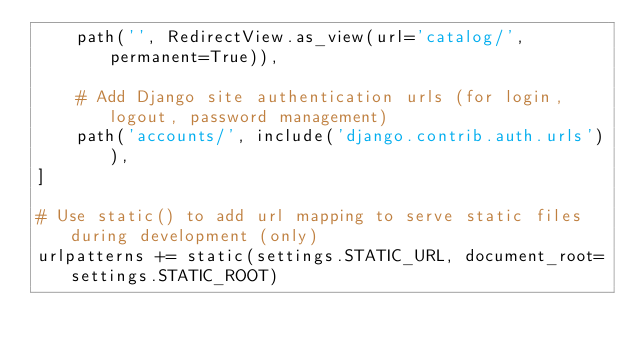Convert code to text. <code><loc_0><loc_0><loc_500><loc_500><_Python_>    path('', RedirectView.as_view(url='catalog/', permanent=True)),

    # Add Django site authentication urls (for login, logout, password management)
    path('accounts/', include('django.contrib.auth.urls')),
]

# Use static() to add url mapping to serve static files during development (only)
urlpatterns += static(settings.STATIC_URL, document_root=settings.STATIC_ROOT)

</code> 